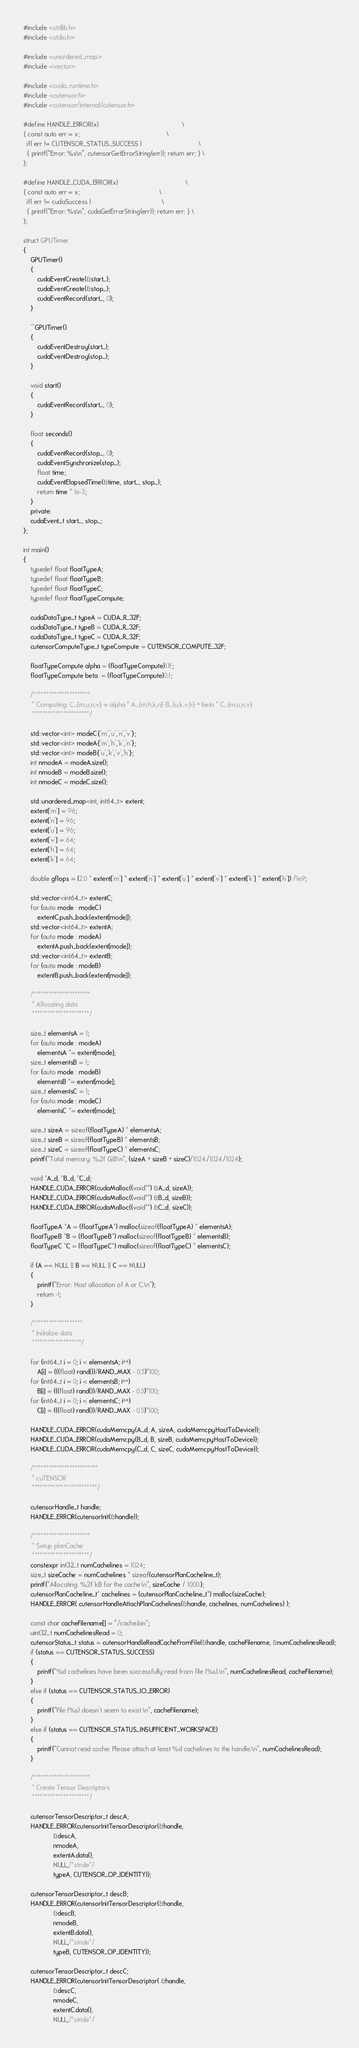<code> <loc_0><loc_0><loc_500><loc_500><_Cuda_>
#include <stdlib.h>
#include <stdio.h>

#include <unordered_map>
#include <vector>

#include <cuda_runtime.h>
#include <cutensor.h>
#include <cutensor/internal/cutensor.h>

#define HANDLE_ERROR(x)                                               \
{ const auto err = x;                                                 \
  if( err != CUTENSOR_STATUS_SUCCESS )                                \
  { printf("Error: %s\n", cutensorGetErrorString(err)); return err; } \
};

#define HANDLE_CUDA_ERROR(x)                                      \
{ const auto err = x;                                             \
  if( err != cudaSuccess )                                        \
  { printf("Error: %s\n", cudaGetErrorString(err)); return err; } \
};

struct GPUTimer
{
    GPUTimer() 
    {
        cudaEventCreate(&start_);
        cudaEventCreate(&stop_);
        cudaEventRecord(start_, 0);
    }

    ~GPUTimer() 
    {
        cudaEventDestroy(start_);
        cudaEventDestroy(stop_);
    }

    void start() 
    {
        cudaEventRecord(start_, 0);
    }

    float seconds() 
    {
        cudaEventRecord(stop_, 0);
        cudaEventSynchronize(stop_);
        float time;
        cudaEventElapsedTime(&time, start_, stop_);
        return time * 1e-3;
    }
    private:
    cudaEvent_t start_, stop_;
};

int main()
{
    typedef float floatTypeA;
    typedef float floatTypeB;
    typedef float floatTypeC;
    typedef float floatTypeCompute;

    cudaDataType_t typeA = CUDA_R_32F;
    cudaDataType_t typeB = CUDA_R_32F;
    cudaDataType_t typeC = CUDA_R_32F;
    cutensorComputeType_t typeCompute = CUTENSOR_COMPUTE_32F;

    floatTypeCompute alpha = (floatTypeCompute)1.1f;
    floatTypeCompute beta  = (floatTypeCompute)0.f;

    /**********************
     * Computing: C_{m,u,n,v} = alpha * A_{m,h,k,n} B_{u,k,v,h} + beta * C_{m,u,n,v}
     **********************/

    std::vector<int> modeC{'m','u','n','v'};
    std::vector<int> modeA{'m','h','k','n'};
    std::vector<int> modeB{'u','k','v','h'};
    int nmodeA = modeA.size();
    int nmodeB = modeB.size();
    int nmodeC = modeC.size();

    std::unordered_map<int, int64_t> extent;
    extent['m'] = 96;
    extent['n'] = 96;
    extent['u'] = 96;
    extent['v'] = 64;
    extent['h'] = 64;
    extent['k'] = 64;

    double gflops = (2.0 * extent['m'] * extent['n'] * extent['u'] * extent['v'] * extent['k'] * extent['h']) /1e9;

    std::vector<int64_t> extentC;
    for (auto mode : modeC)
        extentC.push_back(extent[mode]);
    std::vector<int64_t> extentA;
    for (auto mode : modeA)
        extentA.push_back(extent[mode]);
    std::vector<int64_t> extentB;
    for (auto mode : modeB)
        extentB.push_back(extent[mode]);

    /**********************
     * Allocating data
     **********************/

    size_t elementsA = 1;
    for (auto mode : modeA)
        elementsA *= extent[mode];
    size_t elementsB = 1;
    for (auto mode : modeB)
        elementsB *= extent[mode];
    size_t elementsC = 1;
    for (auto mode : modeC)
        elementsC *= extent[mode];

    size_t sizeA = sizeof(floatTypeA) * elementsA;
    size_t sizeB = sizeof(floatTypeB) * elementsB;
    size_t sizeC = sizeof(floatTypeC) * elementsC;
    printf("Total memory: %.2f GiB\n", (sizeA + sizeB + sizeC)/1024./1024./1024);

    void *A_d, *B_d, *C_d;
    HANDLE_CUDA_ERROR(cudaMalloc((void**) &A_d, sizeA));
    HANDLE_CUDA_ERROR(cudaMalloc((void**) &B_d, sizeB));
    HANDLE_CUDA_ERROR(cudaMalloc((void**) &C_d, sizeC));

    floatTypeA *A = (floatTypeA*) malloc(sizeof(floatTypeA) * elementsA);
    floatTypeB *B = (floatTypeB*) malloc(sizeof(floatTypeB) * elementsB);
    floatTypeC *C = (floatTypeC*) malloc(sizeof(floatTypeC) * elementsC);

    if (A == NULL || B == NULL || C == NULL)
    {
        printf("Error: Host allocation of A or C.\n");
        return -1;
    }

    /*******************
     * Initialize data
     *******************/

    for (int64_t i = 0; i < elementsA; i++)
        A[i] = (((float) rand())/RAND_MAX - 0.5)*100;
    for (int64_t i = 0; i < elementsB; i++)
        B[i] = (((float) rand())/RAND_MAX - 0.5)*100;
    for (int64_t i = 0; i < elementsC; i++)
        C[i] = (((float) rand())/RAND_MAX - 0.5)*100;

    HANDLE_CUDA_ERROR(cudaMemcpy(A_d, A, sizeA, cudaMemcpyHostToDevice));
    HANDLE_CUDA_ERROR(cudaMemcpy(B_d, B, sizeB, cudaMemcpyHostToDevice));
    HANDLE_CUDA_ERROR(cudaMemcpy(C_d, C, sizeC, cudaMemcpyHostToDevice));

    /*************************
     * cuTENSOR
     *************************/ 

    cutensorHandle_t handle;
    HANDLE_ERROR(cutensorInit(&handle));

    /**********************
     * Setup planCache
     **********************/
    constexpr int32_t numCachelines = 1024;
    size_t sizeCache = numCachelines * sizeof(cutensorPlanCacheline_t);
    printf("Allocating: %.2f kB for the cache\n", sizeCache / 1000.);
    cutensorPlanCacheline_t* cachelines = (cutensorPlanCacheline_t*) malloc(sizeCache);
    HANDLE_ERROR( cutensorHandleAttachPlanCachelines(&handle, cachelines, numCachelines) );

    const char cacheFilename[] = "./cache.bin";
    uint32_t numCachelinesRead = 0;
    cutensorStatus_t status = cutensorHandleReadCacheFromFile(&handle, cacheFilename, &numCachelinesRead);
    if (status == CUTENSOR_STATUS_SUCCESS)
    {
        printf("%d cachelines have been successfully read from file (%s).\n", numCachelinesRead, cacheFilename);
    }
    else if (status == CUTENSOR_STATUS_IO_ERROR)
    {
        printf("File (%s) doesn't seem to exist.\n", cacheFilename);
    }
    else if (status == CUTENSOR_STATUS_INSUFFICIENT_WORKSPACE)
    {
        printf("Cannot read cache: Please attach at least %d cachelines to the handle.\n", numCachelinesRead);
    }

    /**********************
     * Create Tensor Descriptors
     **********************/

    cutensorTensorDescriptor_t descA;
    HANDLE_ERROR(cutensorInitTensorDescriptor(&handle,
                 &descA,
                 nmodeA,
                 extentA.data(),
                 NULL,/*stride*/
                 typeA, CUTENSOR_OP_IDENTITY));

    cutensorTensorDescriptor_t descB;
    HANDLE_ERROR(cutensorInitTensorDescriptor(&handle,
                 &descB,
                 nmodeB,
                 extentB.data(),
                 NULL,/*stride*/
                 typeB, CUTENSOR_OP_IDENTITY));

    cutensorTensorDescriptor_t descC;
    HANDLE_ERROR(cutensorInitTensorDescriptor( &handle,
                 &descC,
                 nmodeC,
                 extentC.data(),
                 NULL,/*stride*/</code> 